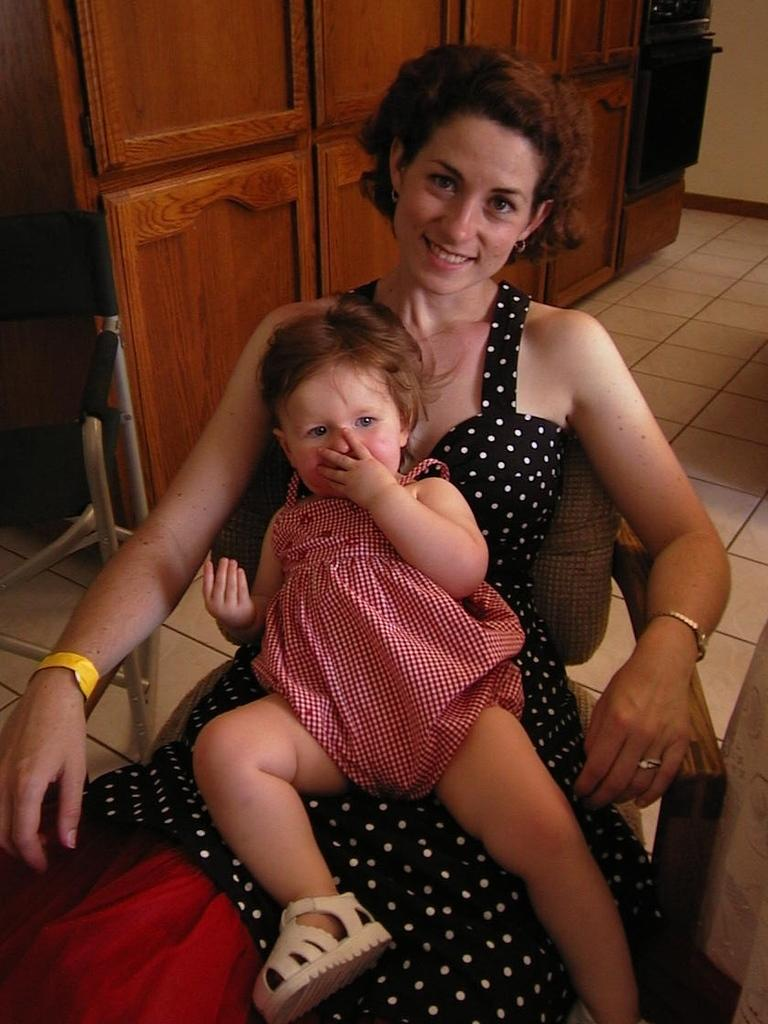Who is the main subject in the image? There is a woman in the center of the image. What is the woman doing in the image? The woman is sitting and holding a baby. What can be seen in the background of the image? There is a chair and a cupboard in the background of the image. What is visible at the bottom of the image? There is a floor visible at the bottom of the image. What type of hill can be seen in the background of the image? There is no hill visible in the background of the image. What month is the woman holding the baby in the image? The image does not provide information about the month or time of year. 